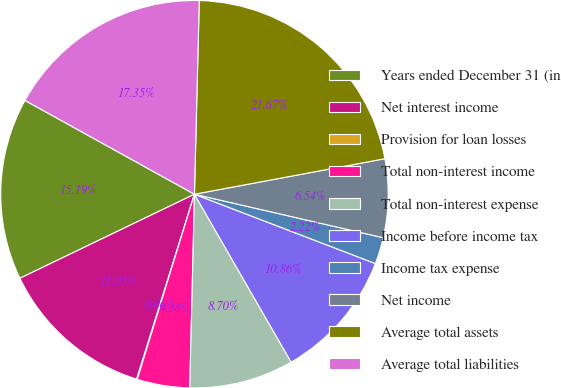Convert chart to OTSL. <chart><loc_0><loc_0><loc_500><loc_500><pie_chart><fcel>Years ended December 31 (in<fcel>Net interest income<fcel>Provision for loan losses<fcel>Total non-interest income<fcel>Total non-interest expense<fcel>Income before income tax<fcel>Income tax expense<fcel>Net income<fcel>Average total assets<fcel>Average total liabilities<nl><fcel>15.19%<fcel>13.03%<fcel>0.06%<fcel>4.38%<fcel>8.7%<fcel>10.86%<fcel>2.22%<fcel>6.54%<fcel>21.67%<fcel>17.35%<nl></chart> 